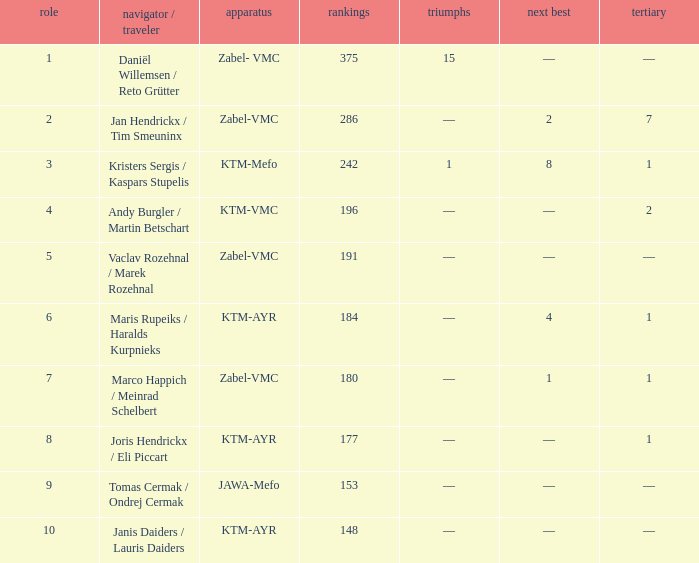What was the highest points when the second was 4? 184.0. Could you help me parse every detail presented in this table? {'header': ['role', 'navigator / traveler', 'apparatus', 'rankings', 'triumphs', 'next best', 'tertiary'], 'rows': [['1', 'Daniël Willemsen / Reto Grütter', 'Zabel- VMC', '375', '15', '—', '—'], ['2', 'Jan Hendrickx / Tim Smeuninx', 'Zabel-VMC', '286', '—', '2', '7'], ['3', 'Kristers Sergis / Kaspars Stupelis', 'KTM-Mefo', '242', '1', '8', '1'], ['4', 'Andy Burgler / Martin Betschart', 'KTM-VMC', '196', '—', '—', '2'], ['5', 'Vaclav Rozehnal / Marek Rozehnal', 'Zabel-VMC', '191', '—', '—', '—'], ['6', 'Maris Rupeiks / Haralds Kurpnieks', 'KTM-AYR', '184', '—', '4', '1'], ['7', 'Marco Happich / Meinrad Schelbert', 'Zabel-VMC', '180', '—', '1', '1'], ['8', 'Joris Hendrickx / Eli Piccart', 'KTM-AYR', '177', '—', '—', '1'], ['9', 'Tomas Cermak / Ondrej Cermak', 'JAWA-Mefo', '153', '—', '—', '—'], ['10', 'Janis Daiders / Lauris Daiders', 'KTM-AYR', '148', '—', '—', '—']]} 